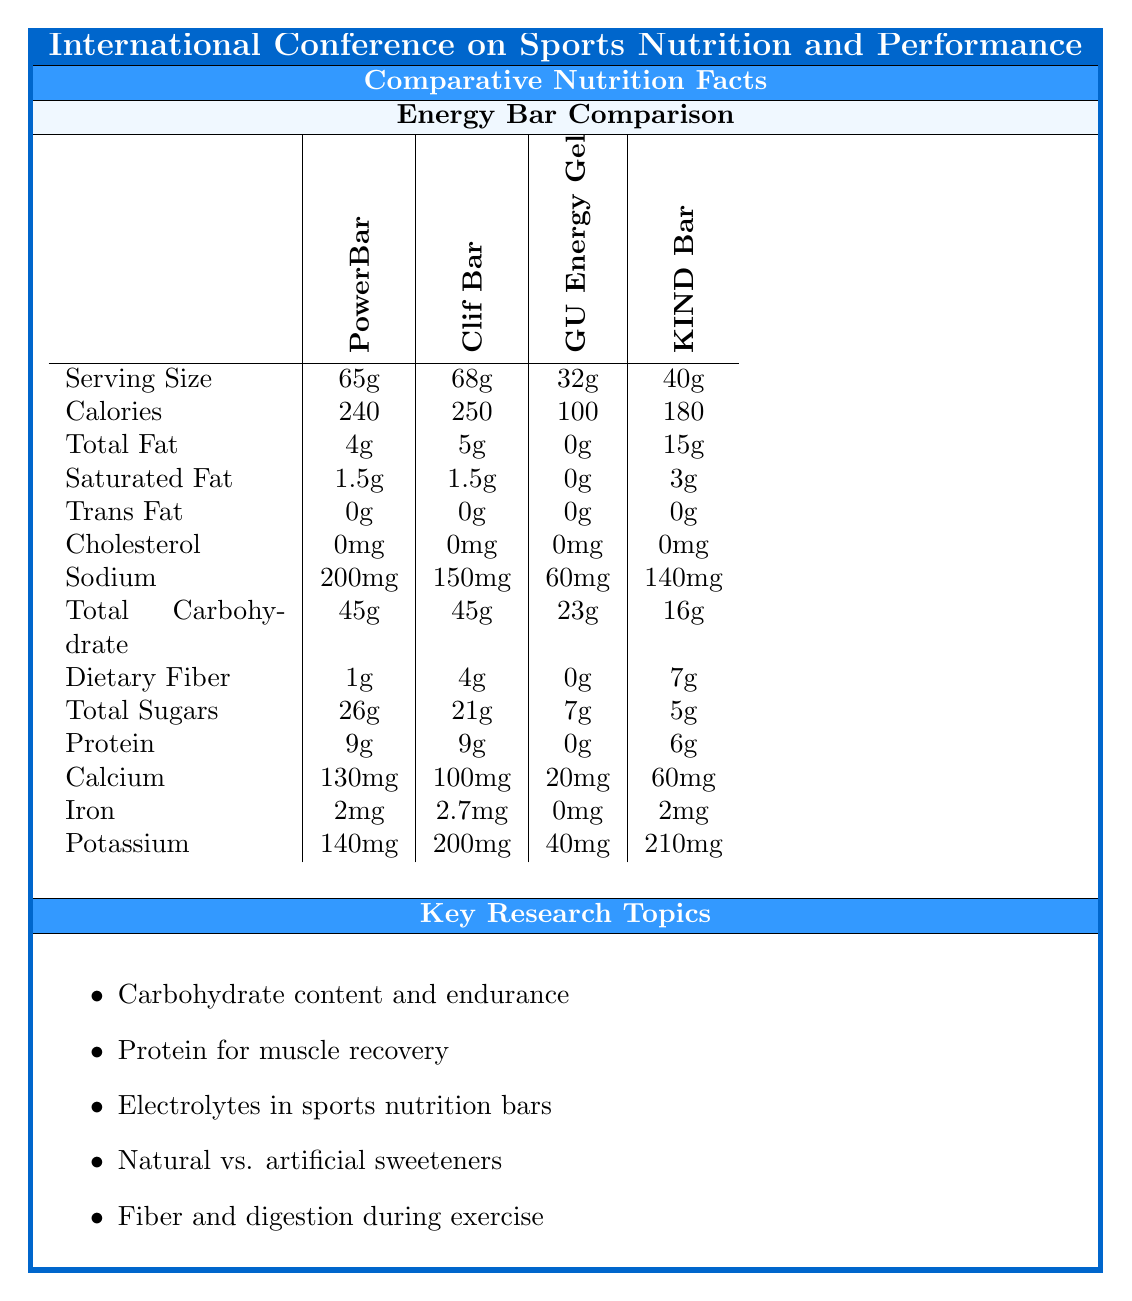what is the serving size of the PowerBar Performance Energy? The document lists the serving size of PowerBar Performance Energy as 65g.
Answer: 65g which energy bar has the highest amount of total fat? A. PowerBar Performance Energy B. Clif Bar Chocolate Chip C. GU Energy Original Sports Nutrition Energy Gel D. KIND Bars Dark Chocolate Nuts & Sea Salt The KIND Bars Dark Chocolate Nuts & Sea Salt has 15g of total fat, which is the highest among the listed energy bars.
Answer: D how much protein is in the Clif Bar Chocolate Chip? The document states that the Clif Bar Chocolate Chip contains 9g of protein.
Answer: 9g what is the amount of dietary fiber in the GU Energy Original Sports Nutrition Energy Gel? According to the document, the GU Energy Original Sports Nutrition Energy Gel contains 0g of dietary fiber.
Answer: 0g how much calcium does the PowerBar Performance Energy contain? The document lists the calcium content of the PowerBar Performance Energy as 130mg.
Answer: 130mg which energy bar has the lowest sodium content? A. PowerBar Performance Energy B. Clif Bar Chocolate Chip C. GU Energy Original Sports Nutrition Energy Gel D. KIND Bars Dark Chocolate Nuts & Sea Salt The GU Energy Original Sports Nutrition Energy Gel has 60mg of sodium, which is the lowest among the listed energy bars.
Answer: C do any of the energy bars contain cholesterol? The document states that none of the listed energy bars contain cholesterol.
Answer: No summarize the main idea of the document. The detailed summary explains that the document focuses on comparing the nutritional content of different energy bars, highlighting various macronutrients, micronutrients, and relevant research topics within sports nutrition.
Answer: The document provides a comparative analysis of the nutritional content of various energy bars for athletes. It includes information on serving size, calories, fats, cholesterol, sodium, carbohydrates, dietary fiber, sugars, protein, calcium, iron, and potassium for each energy bar. Additionally, it outlines key research topics related to sports nutrition. which energy bar has the highest iron content? The Clif Bar Chocolate Chip contains 2.7mg of iron, which is the highest among the energy bars listed.
Answer: Clif Bar Chocolate Chip how many grams of saturated fat does the KIND Bars Dark Chocolate Nuts & Sea Salt contain? The document specifies that KIND Bars Dark Chocolate Nuts & Sea Salt contain 3g of saturated fat.
Answer: 3g what is the primary focus of the research topics listed in the document? The research topics are centered around understanding the nutritional needs and impacts on athletes, primarily focusing on macronutrients, electrolytes, sweeteners, and fiber.
Answer: The primary focus is on various aspects of sports nutrition, including carbohydrate content and its impact on endurance, protein requirements for muscle recovery, electrolytes in sports nutrition bars, comparing natural vs. artificial sweeteners, and fiber content and its effects on digestion during exercise. what are the total carbohydrates in the Clif Bar Chocolate Chip? The document states that the Clif Bar Chocolate Chip contains 45g of total carbohydrates.
Answer: 45g which energy bar has the least total sugars? The KIND Bars Dark Chocolate Nuts & Sea Salt have 5g of total sugars, which is the lowest amount listed.
Answer: KIND Bars Dark Chocolate Nuts & Sea Salt which energy bar contains the most calories? A. PowerBar Performance Energy B. Clif Bar Chocolate Chip C. GU Energy Original Sports Nutrition Energy Gel D. KIND Bars Dark Chocolate Nuts & Sea Salt The Clif Bar Chocolate Chip contains 250 calories, the highest among the listed energy bars.
Answer: B what is the glycemic index of the PowerBar Performance Energy? The document does not provide any details regarding the glycemic index of the energy bars, so it's not possible to answer this question based on the provided information.
Answer: Not enough information which energy bar contains potassium more than 200mg? According to the document, the KIND Bars Dark Chocolate Nuts & Sea Salt contain 210mg of potassium, which is more than 200mg.
Answer: KIND Bars Dark Chocolate Nuts & Sea Salt 